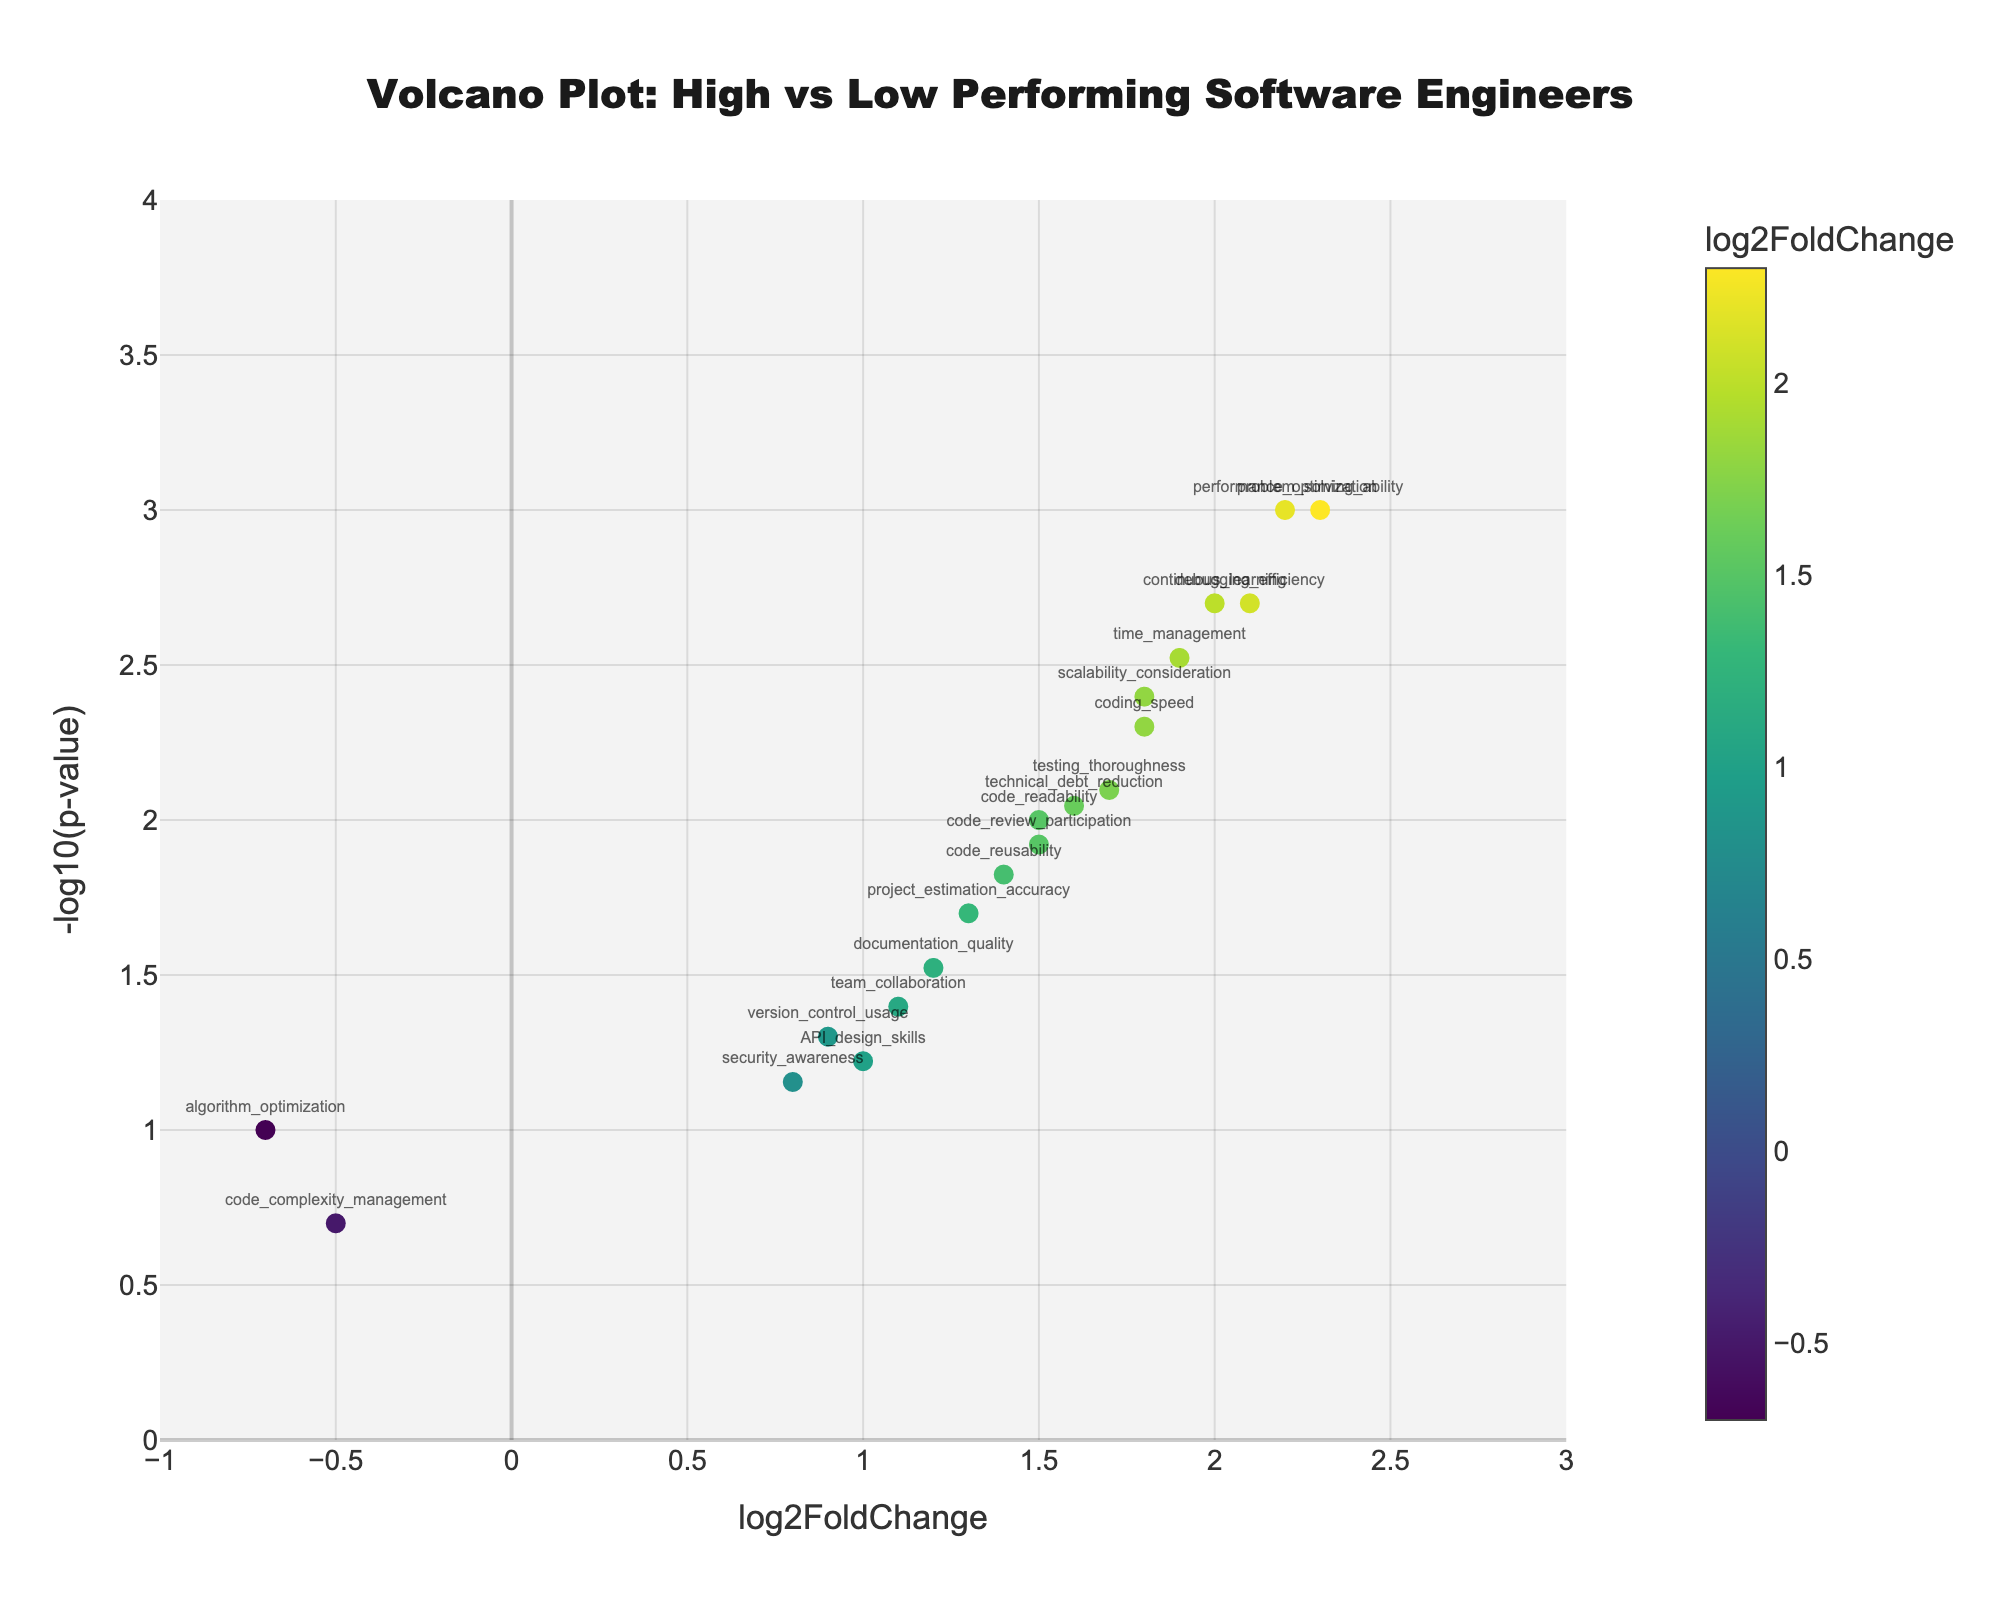What's the title of the figure? The title is located at the top of the figure and is often indicated with larger and bold font.
Answer: Volcano Plot: High vs Low Performing Software Engineers What are the axes labels? The x-axis label is found horizontally at the bottom of the plot, and the y-axis label is found vertically on the left side of the plot.
Answer: x-axis: log2FoldChange, y-axis: -log10(p-value) How many genes have a log2FoldChange greater than 1? To determine this, scan the x-axis for data points that fall to the right of the value 1.
Answer: 15 Which gene has the highest -log10(p-value)? Locate the highest point on the y-axis and look at the gene label next to it.
Answer: problem_solving_ability Which gene has the lowest log2FoldChange? Identify the data point that is furthest to the left on the x-axis and check the gene label next to it.
Answer: algorithm_optimization What is the log2FoldChange and -log10(p-value) for debugging_efficiency? Find the point labeled "debugging_efficiency" and read its x (log2FoldChange) and y (-log10(p-value)) coordinates.
Answer: log2FoldChange: 2.1, -log10(p-value): 2.70 What is the sum of log2FoldChange for continuous_learning and performance_optimization? Identify the log2FoldChange for both genes and add them together.
Answer: 2.0 + 2.2 = 4.2 Which gene has a higher p-value: version_control_usage or security_awareness? Compare the y-coordinates of these two points since p-value is inversely related to -log10(p-value). The higher the y-coordinate, the lower the p-value, and vice versa.
Answer: security_awareness How many data points represent genes with a p-value less than 0.01? Convert the p-value of 0.01 to -log10, which is 2, then count all points above this threshold on the y-axis.
Answer: 8 Is the relationship between log2FoldChange and -log10(p-value) directly or inversely proportional? Observe the general trend in the data points. If higher log2FoldChange generally coincides with higher -log10(p-value), it’s direct; otherwise, it’s inverse.
Answer: Direct 